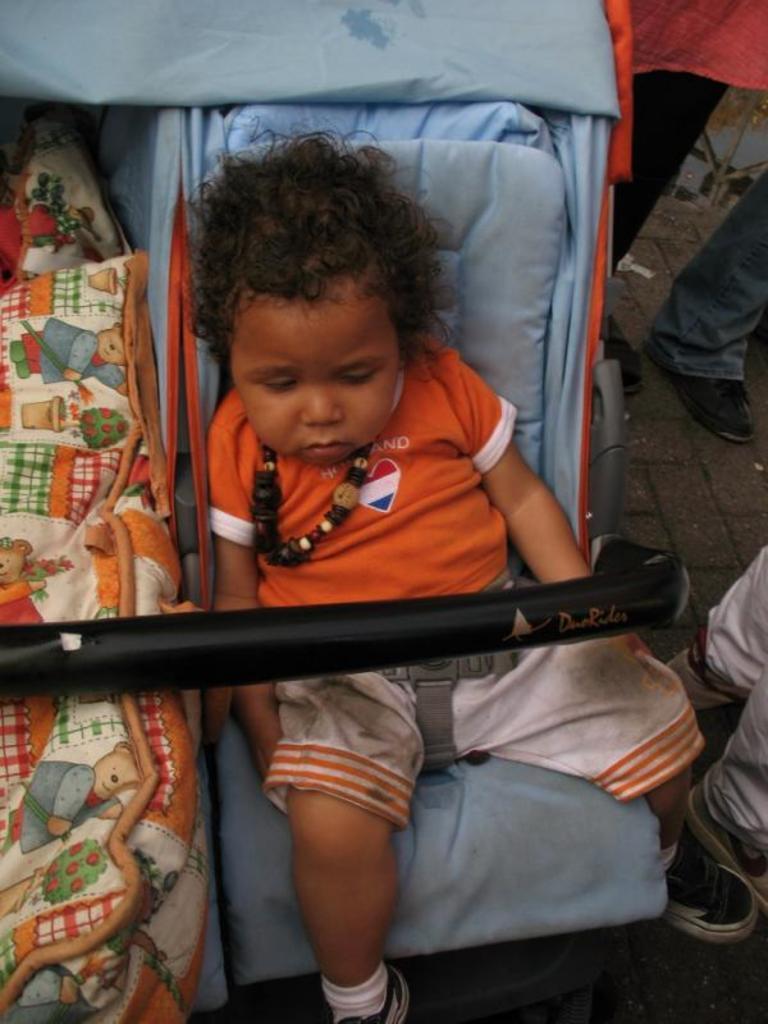How would you summarize this image in a sentence or two? In this picture, I see a kid seated on the baby trolley and and we see another baby trolley on the left side and i see few human legs on the right side of the picture. 